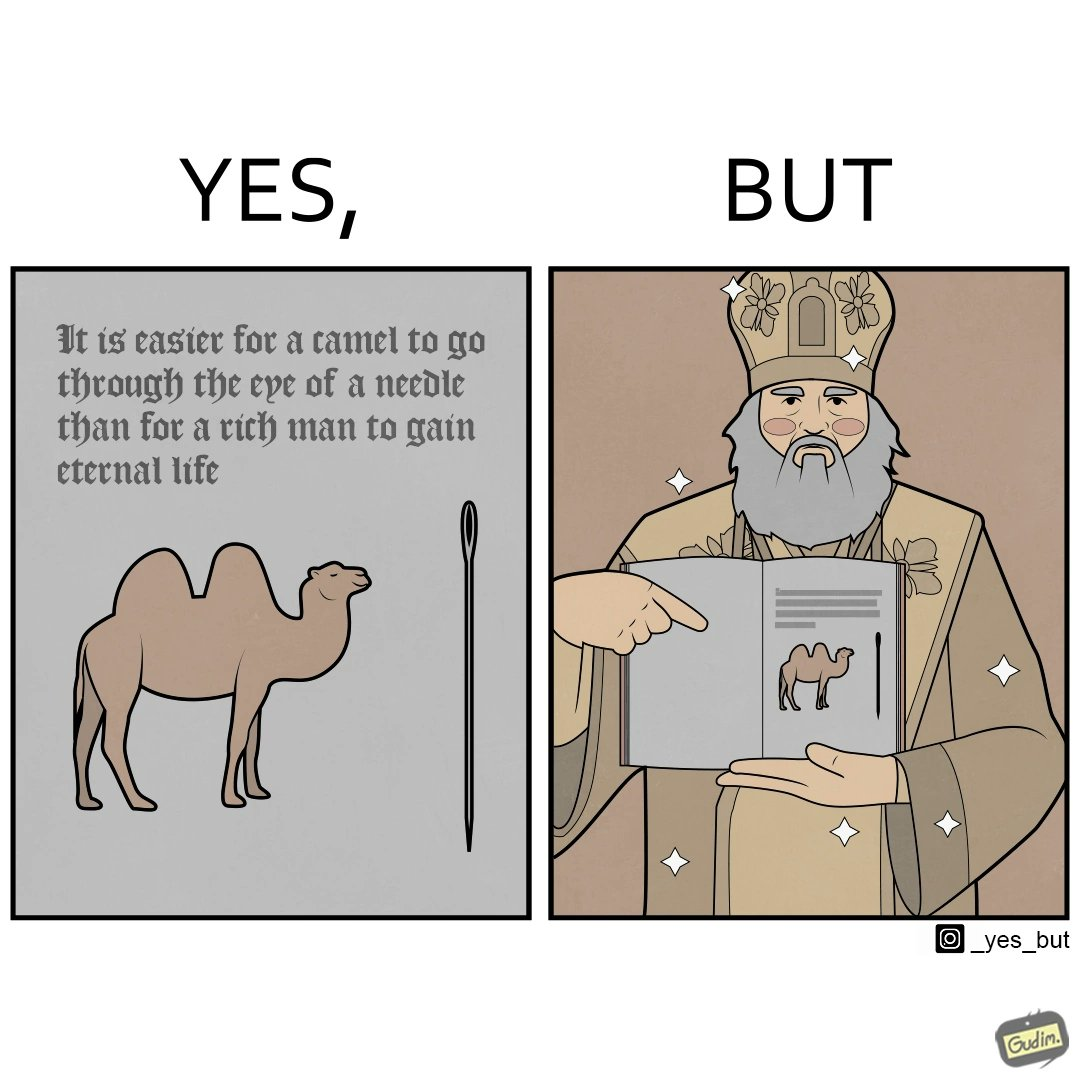Describe the content of this image. The image is ironic, because an old man with good looking clothes, symbolising him as rich, is showing a quote on the difficulty for a rich man to gain eternal life whereas the man has both long life meaning eternal life and good clothes meaning rich 